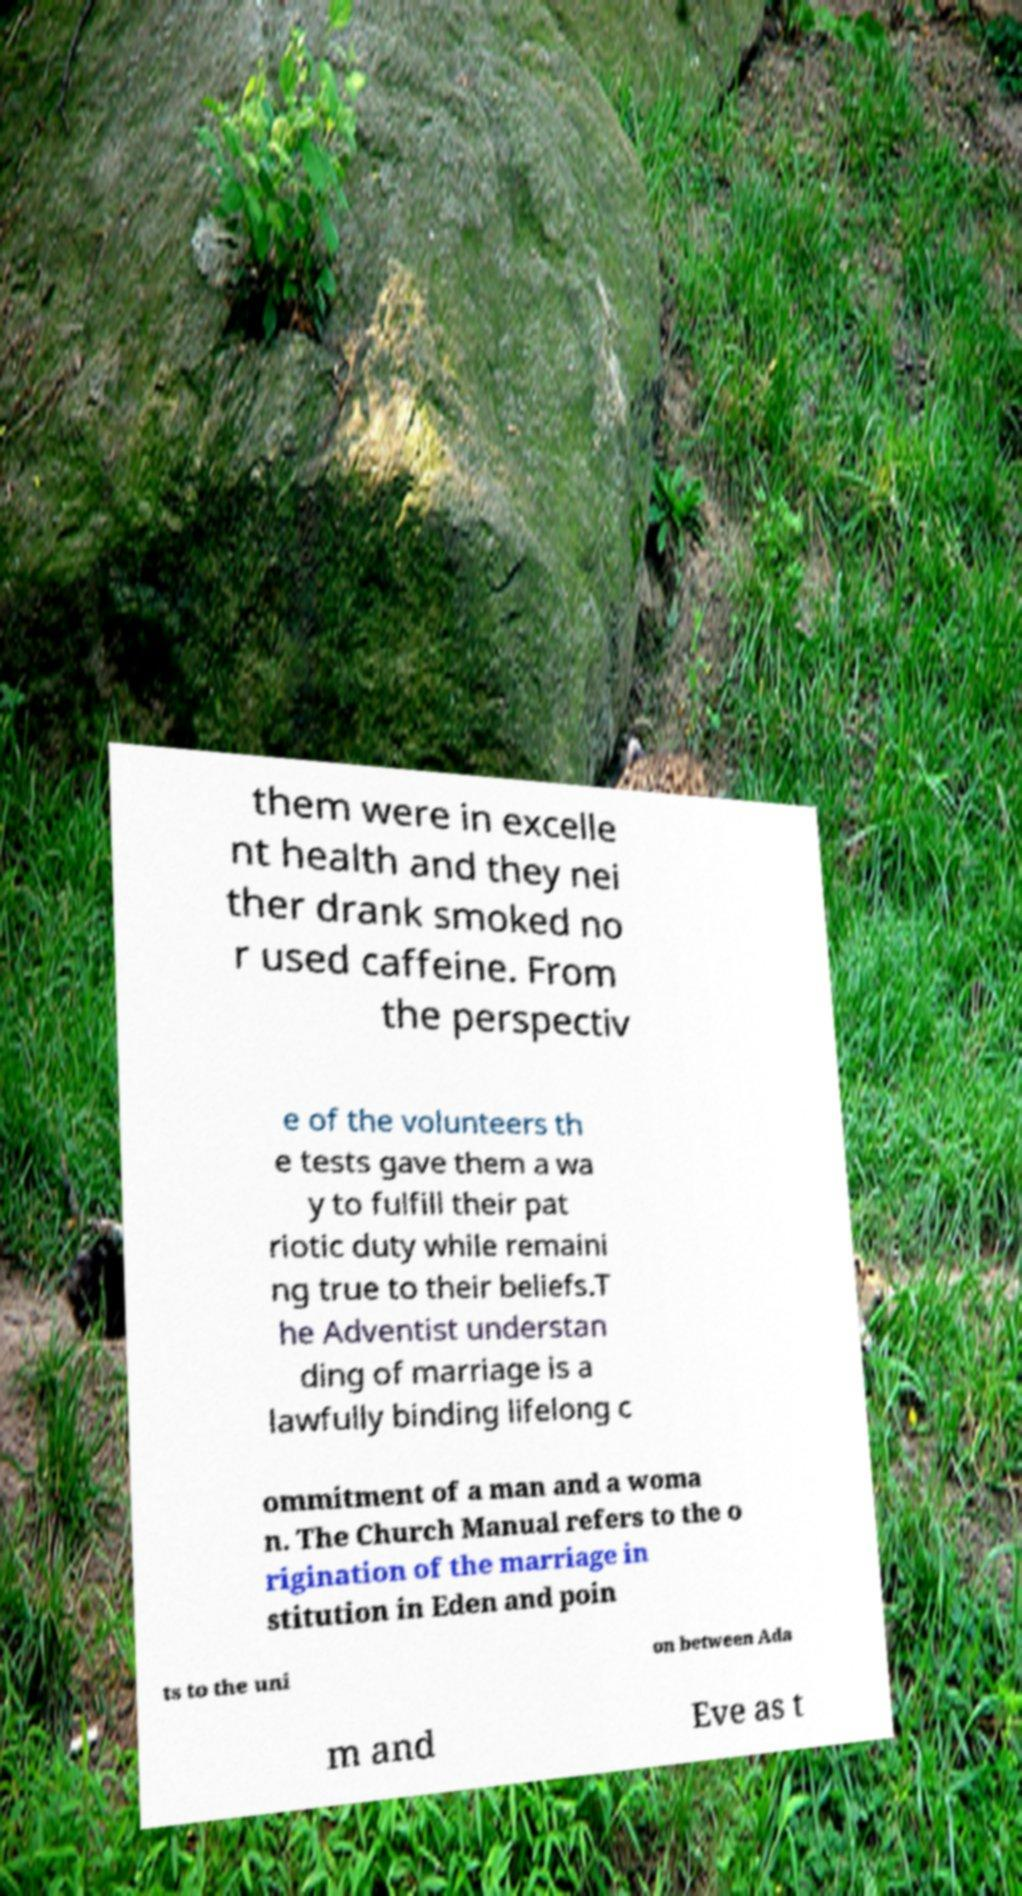I need the written content from this picture converted into text. Can you do that? them were in excelle nt health and they nei ther drank smoked no r used caffeine. From the perspectiv e of the volunteers th e tests gave them a wa y to fulfill their pat riotic duty while remaini ng true to their beliefs.T he Adventist understan ding of marriage is a lawfully binding lifelong c ommitment of a man and a woma n. The Church Manual refers to the o rigination of the marriage in stitution in Eden and poin ts to the uni on between Ada m and Eve as t 